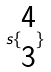Convert formula to latex. <formula><loc_0><loc_0><loc_500><loc_500>s \{ \begin{matrix} 4 \\ 3 \end{matrix} \}</formula> 